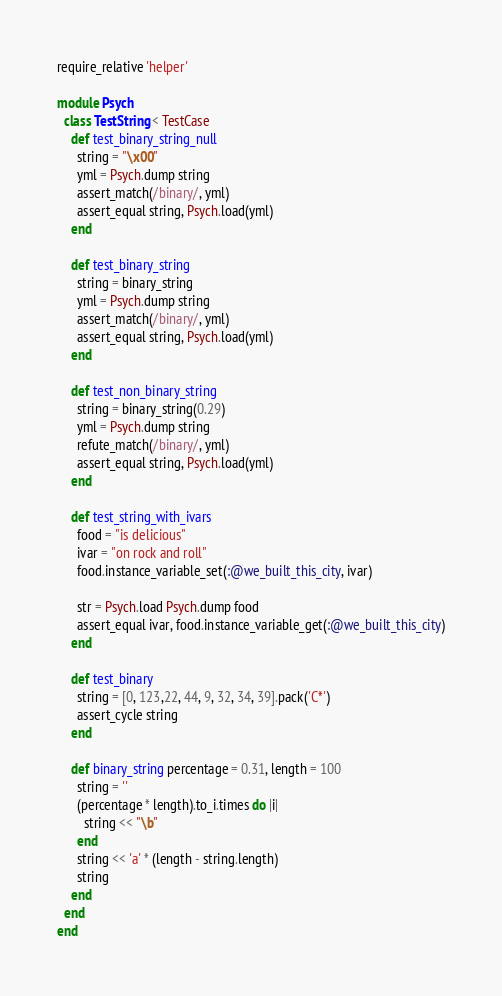Convert code to text. <code><loc_0><loc_0><loc_500><loc_500><_Ruby_>require_relative 'helper'

module Psych
  class TestString < TestCase
    def test_binary_string_null
      string = "\x00"
      yml = Psych.dump string
      assert_match(/binary/, yml)
      assert_equal string, Psych.load(yml)
    end

    def test_binary_string
      string = binary_string
      yml = Psych.dump string
      assert_match(/binary/, yml)
      assert_equal string, Psych.load(yml)
    end

    def test_non_binary_string
      string = binary_string(0.29)
      yml = Psych.dump string
      refute_match(/binary/, yml)
      assert_equal string, Psych.load(yml)
    end

    def test_string_with_ivars
      food = "is delicious"
      ivar = "on rock and roll"
      food.instance_variable_set(:@we_built_this_city, ivar)

      str = Psych.load Psych.dump food
      assert_equal ivar, food.instance_variable_get(:@we_built_this_city)
    end

    def test_binary
      string = [0, 123,22, 44, 9, 32, 34, 39].pack('C*')
      assert_cycle string
    end

    def binary_string percentage = 0.31, length = 100
      string = ''
      (percentage * length).to_i.times do |i|
        string << "\b"
      end
      string << 'a' * (length - string.length)
      string
    end
  end
end
</code> 